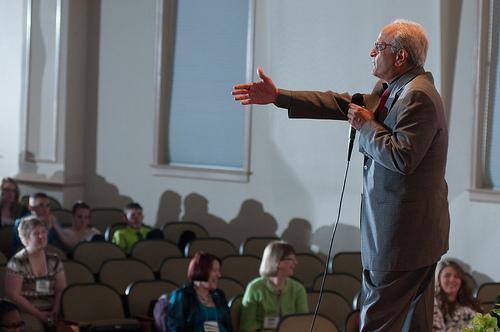How many people are standing?
Give a very brief answer. 1. How many people are wearing green?
Give a very brief answer. 2. 